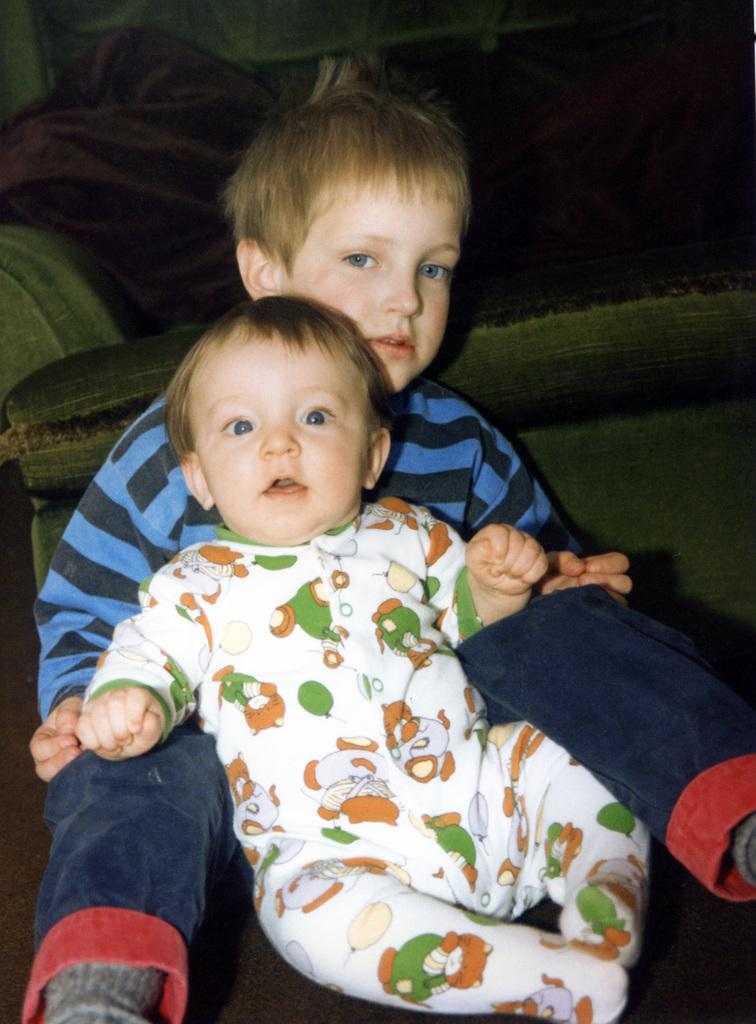Who is present in the image? There are children in the image. What are the children doing in the image? The children are sitting on the floor. What type of operation is being performed by the minister in the image? There is no minister or operation present in the image; it features children sitting on the floor. 